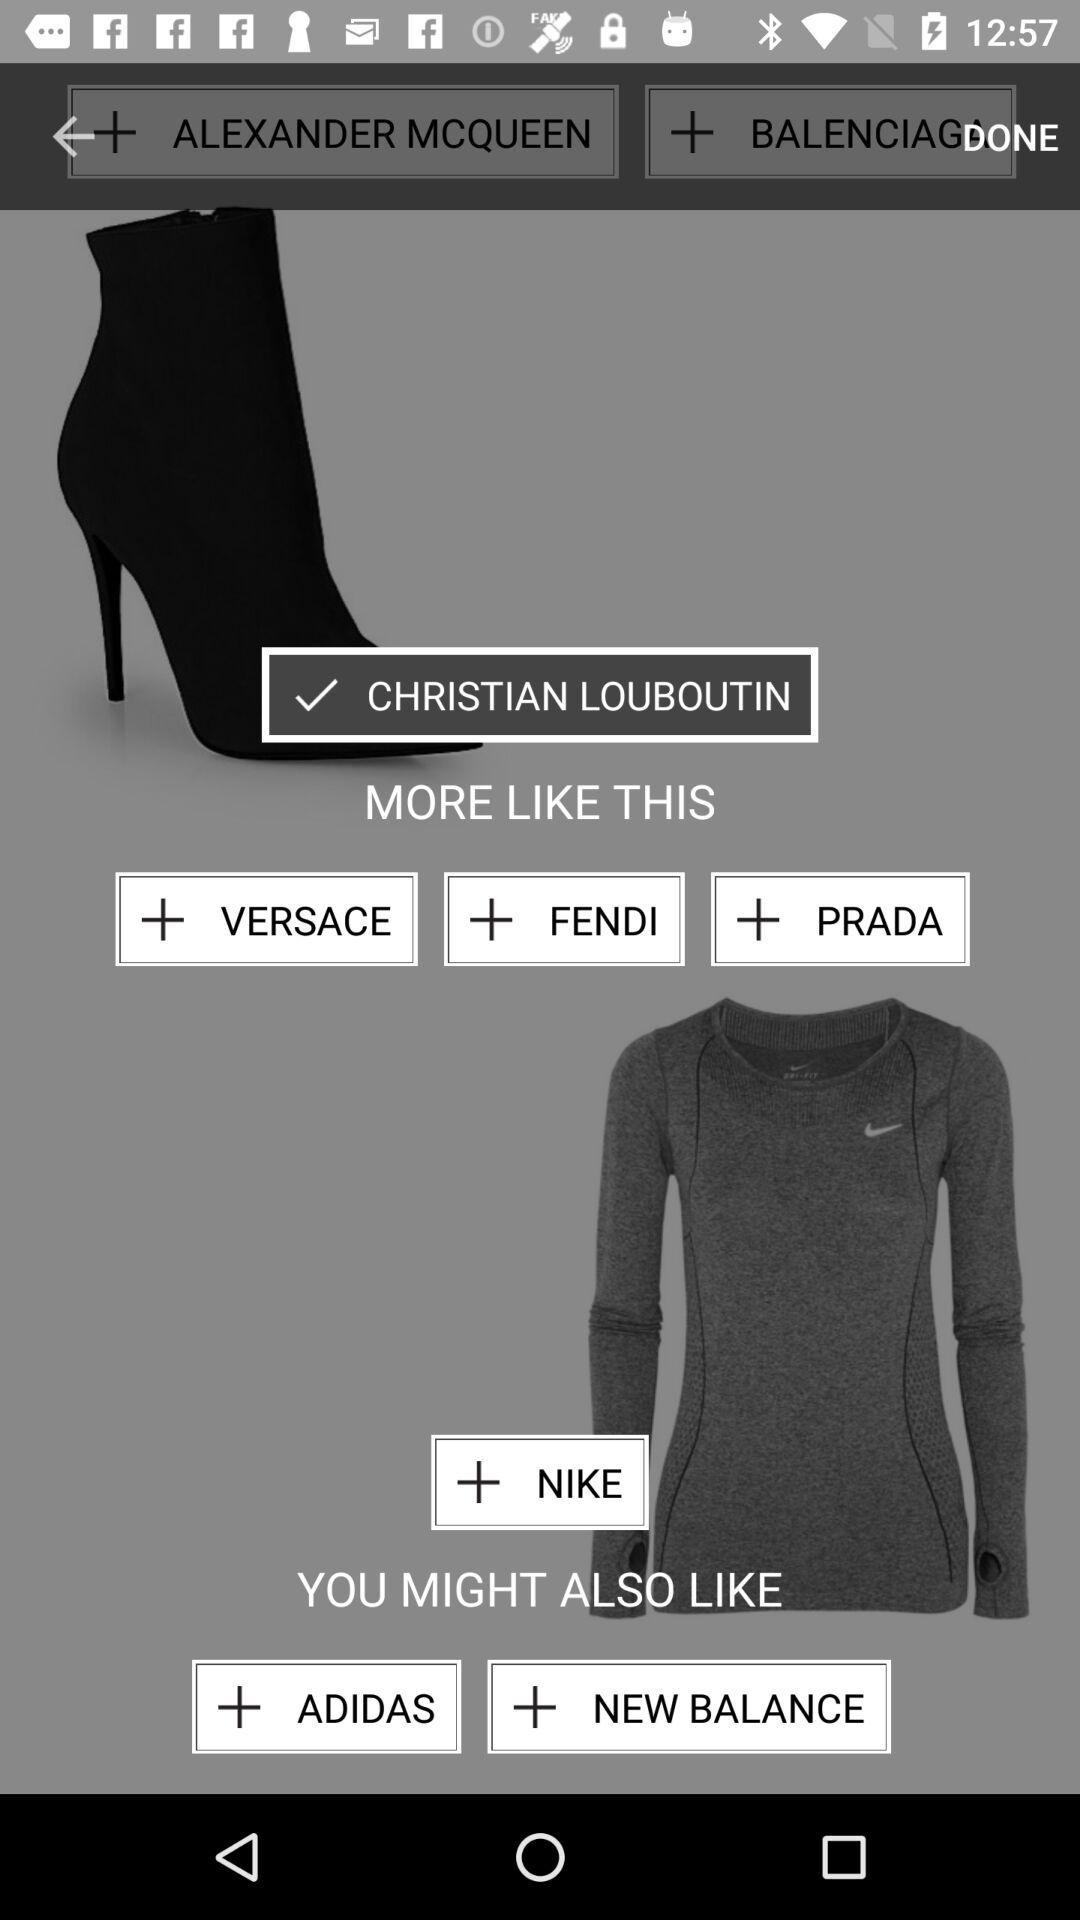What size are the shoes?
When the provided information is insufficient, respond with <no answer>. <no answer> 